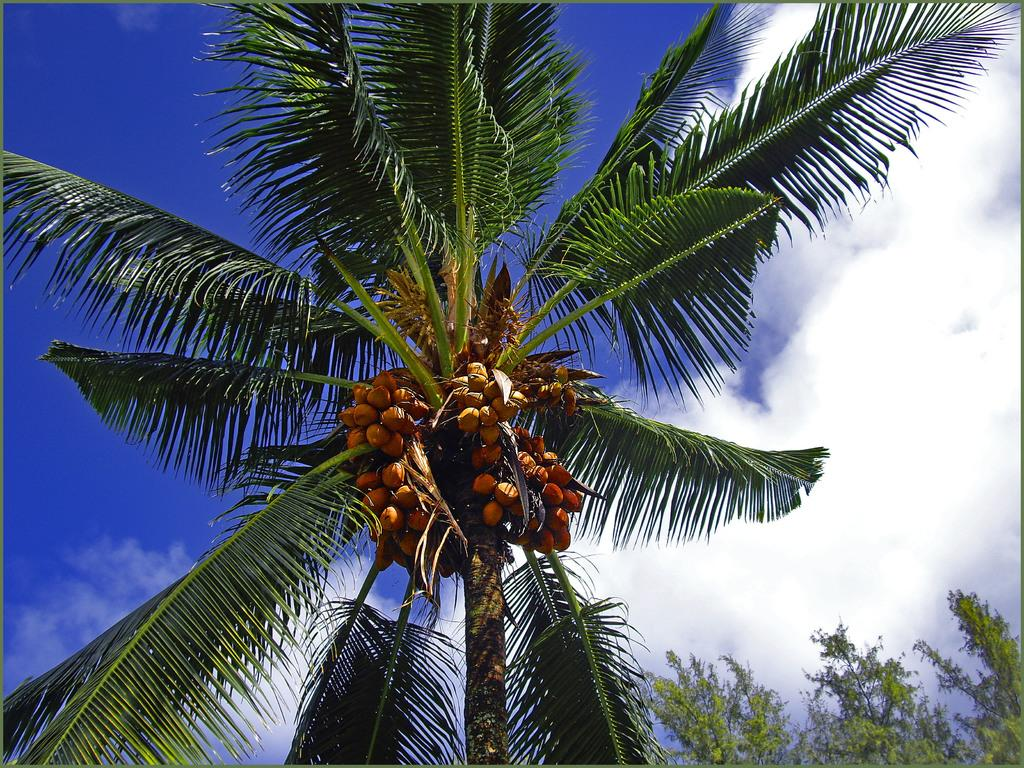What type of vegetation can be seen in the image? There are trees in the image. What can be found on the trees in the image? There are coconuts in the image. What is visible in the background of the image? The sky is visible in the background of the image. What can be observed in the sky? Clouds are present in the sky. What is the opinion of the drug on the plough in the image? There is no drug or plough present in the image, so it is not possible to determine an opinion on them. 